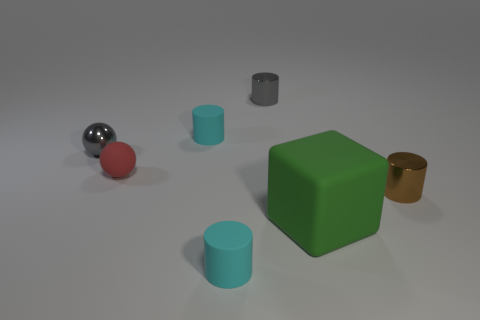Subtract all tiny brown metal cylinders. How many cylinders are left? 3 Subtract all gray blocks. How many cyan cylinders are left? 2 Add 1 red rubber objects. How many objects exist? 8 Subtract all cyan cylinders. How many cylinders are left? 2 Subtract all cylinders. How many objects are left? 3 Subtract 1 balls. How many balls are left? 1 Subtract all blue cylinders. Subtract all purple cubes. How many cylinders are left? 4 Subtract all gray spheres. Subtract all small brown objects. How many objects are left? 5 Add 1 small rubber cylinders. How many small rubber cylinders are left? 3 Add 6 large brown cylinders. How many large brown cylinders exist? 6 